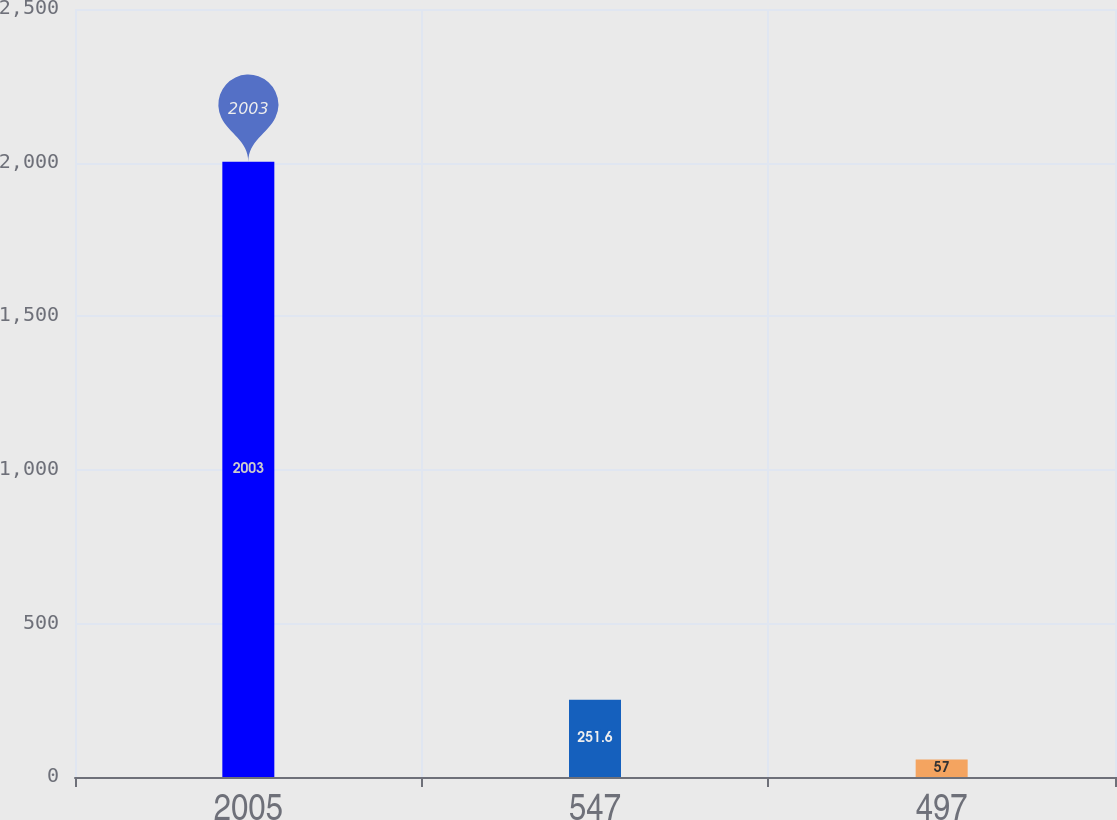Convert chart. <chart><loc_0><loc_0><loc_500><loc_500><bar_chart><fcel>2005<fcel>547<fcel>497<nl><fcel>2003<fcel>251.6<fcel>57<nl></chart> 